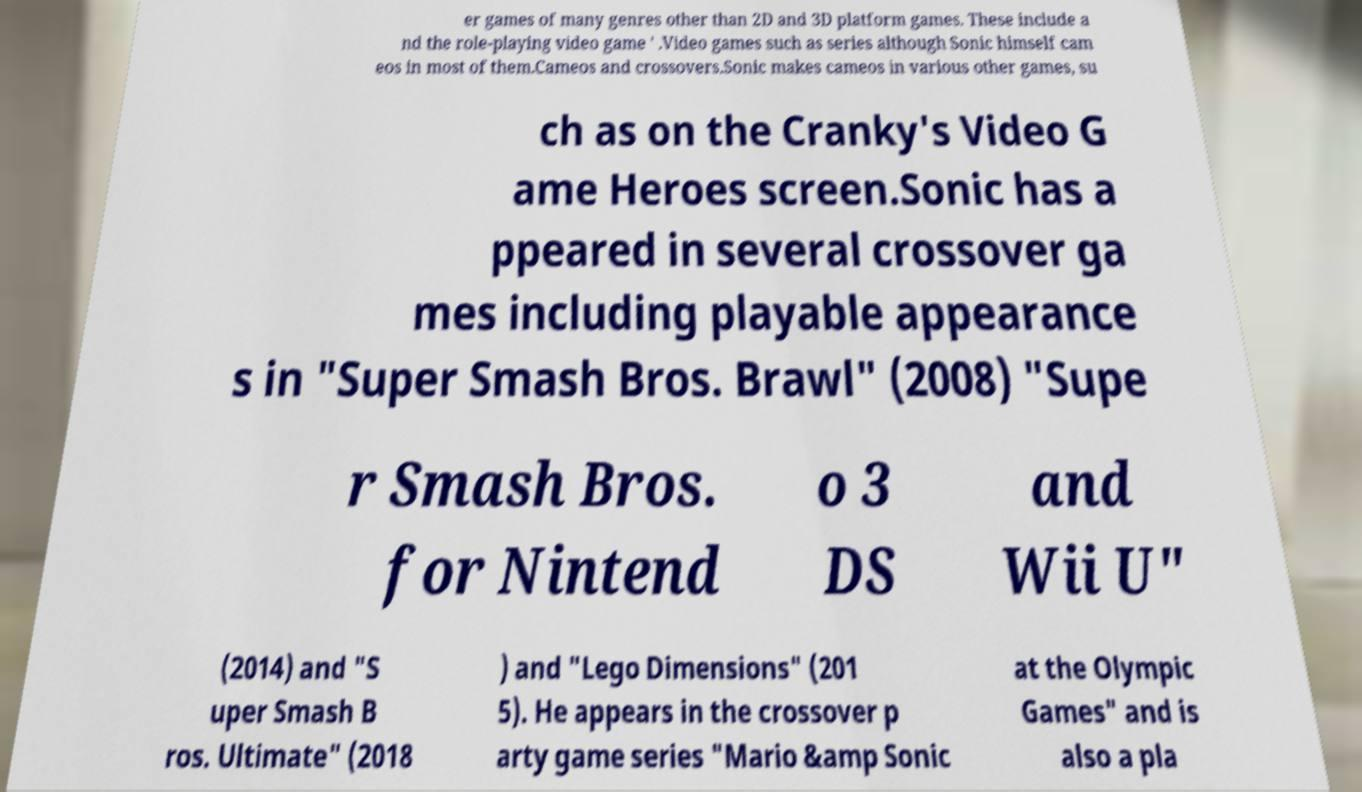I need the written content from this picture converted into text. Can you do that? er games of many genres other than 2D and 3D platform games. These include a nd the role-playing video game ' .Video games such as series although Sonic himself cam eos in most of them.Cameos and crossovers.Sonic makes cameos in various other games, su ch as on the Cranky's Video G ame Heroes screen.Sonic has a ppeared in several crossover ga mes including playable appearance s in "Super Smash Bros. Brawl" (2008) "Supe r Smash Bros. for Nintend o 3 DS and Wii U" (2014) and "S uper Smash B ros. Ultimate" (2018 ) and "Lego Dimensions" (201 5). He appears in the crossover p arty game series "Mario &amp Sonic at the Olympic Games" and is also a pla 